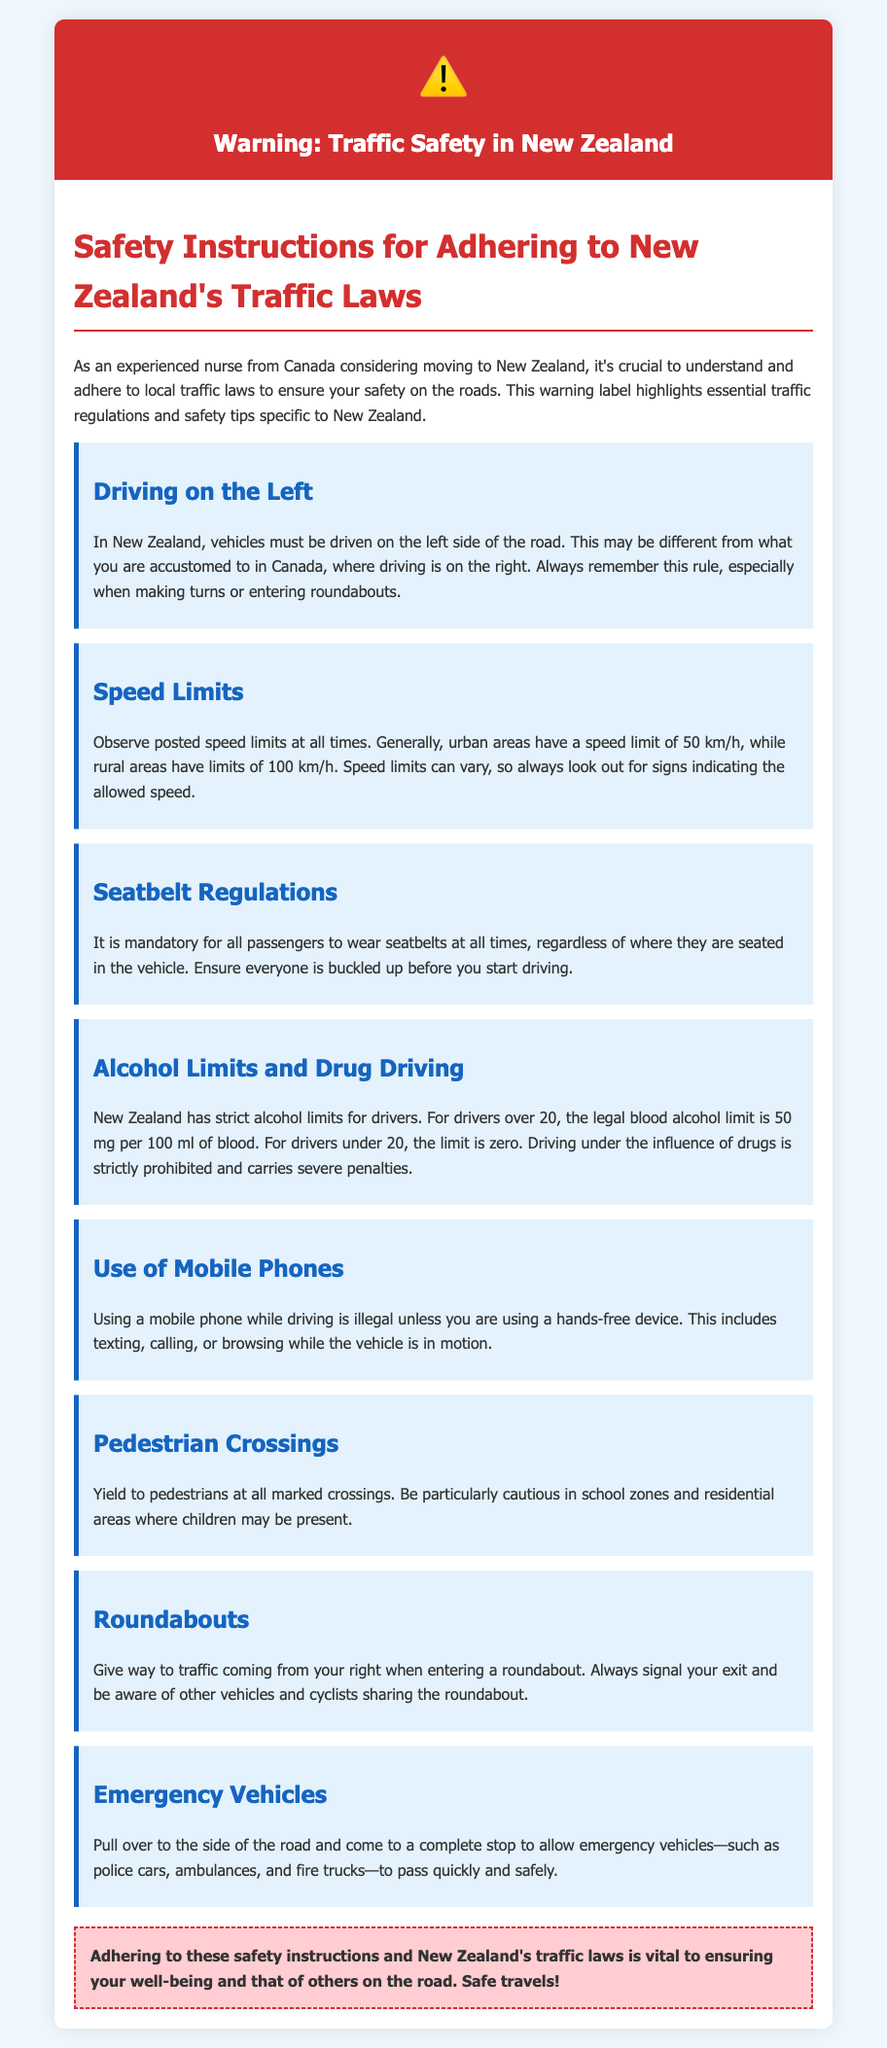What side of the road do you drive on in New Zealand? The document specifies that vehicles must be driven on the left side of the road in New Zealand.
Answer: Left What is the urban speed limit in New Zealand? According to the document, the speed limit in urban areas is 50 km/h.
Answer: 50 km/h Is it mandatory for all passengers to wear seatbelts? The document states that it is mandatory for all passengers to wear seatbelts at all times.
Answer: Yes What is the blood alcohol limit for drivers over 20? The document indicates that the legal blood alcohol limit for drivers over 20 is 50 mg per 100 ml of blood.
Answer: 50 mg per 100 ml What must you do when an emergency vehicle approaches? The document advises to pull over to the side of the road and come to a complete stop to allow emergency vehicles to pass.
Answer: Pull over and stop What do you need to do at pedestrian crossings? As mentioned in the document, you must yield to pedestrians at all marked crossings.
Answer: Yield to pedestrians When entering a roundabout, who do you give way to? The document instructs that you must give way to traffic coming from your right when entering a roundabout.
Answer: Traffic from the right What happens if you drive under the influence of drugs? The document states that driving under the influence of drugs is strictly prohibited and carries severe penalties.
Answer: Severe penalties Is using a mobile phone while driving allowed? According to the document, using a mobile phone while driving is illegal unless using a hands-free device.
Answer: No 